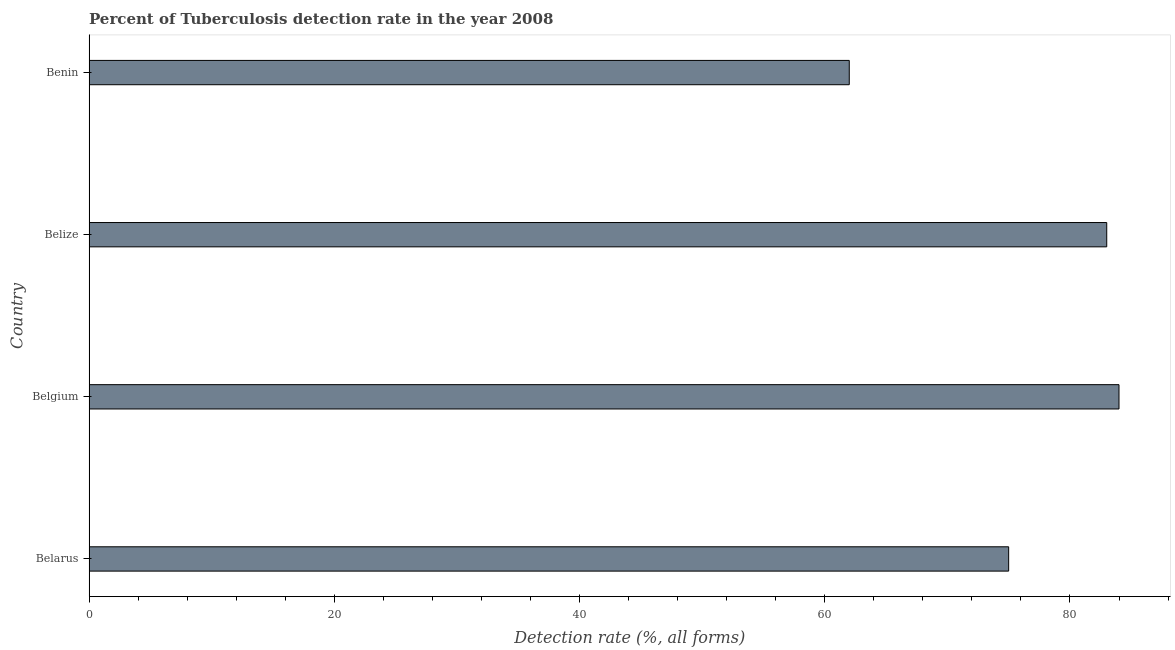Does the graph contain grids?
Provide a succinct answer. No. What is the title of the graph?
Provide a succinct answer. Percent of Tuberculosis detection rate in the year 2008. What is the label or title of the X-axis?
Give a very brief answer. Detection rate (%, all forms). What is the label or title of the Y-axis?
Make the answer very short. Country. What is the detection rate of tuberculosis in Belize?
Provide a succinct answer. 83. In which country was the detection rate of tuberculosis minimum?
Give a very brief answer. Benin. What is the sum of the detection rate of tuberculosis?
Ensure brevity in your answer.  304. What is the average detection rate of tuberculosis per country?
Give a very brief answer. 76. What is the median detection rate of tuberculosis?
Give a very brief answer. 79. Is the detection rate of tuberculosis in Belgium less than that in Belize?
Keep it short and to the point. No. What is the difference between the highest and the second highest detection rate of tuberculosis?
Your response must be concise. 1. What is the difference between the highest and the lowest detection rate of tuberculosis?
Give a very brief answer. 22. How many bars are there?
Keep it short and to the point. 4. Are all the bars in the graph horizontal?
Give a very brief answer. Yes. How many countries are there in the graph?
Make the answer very short. 4. What is the difference between two consecutive major ticks on the X-axis?
Provide a short and direct response. 20. What is the Detection rate (%, all forms) of Belgium?
Keep it short and to the point. 84. What is the Detection rate (%, all forms) of Belize?
Give a very brief answer. 83. What is the difference between the Detection rate (%, all forms) in Belarus and Belgium?
Give a very brief answer. -9. What is the difference between the Detection rate (%, all forms) in Belarus and Belize?
Offer a terse response. -8. What is the difference between the Detection rate (%, all forms) in Belarus and Benin?
Offer a very short reply. 13. What is the ratio of the Detection rate (%, all forms) in Belarus to that in Belgium?
Keep it short and to the point. 0.89. What is the ratio of the Detection rate (%, all forms) in Belarus to that in Belize?
Keep it short and to the point. 0.9. What is the ratio of the Detection rate (%, all forms) in Belarus to that in Benin?
Provide a succinct answer. 1.21. What is the ratio of the Detection rate (%, all forms) in Belgium to that in Benin?
Provide a succinct answer. 1.35. What is the ratio of the Detection rate (%, all forms) in Belize to that in Benin?
Keep it short and to the point. 1.34. 